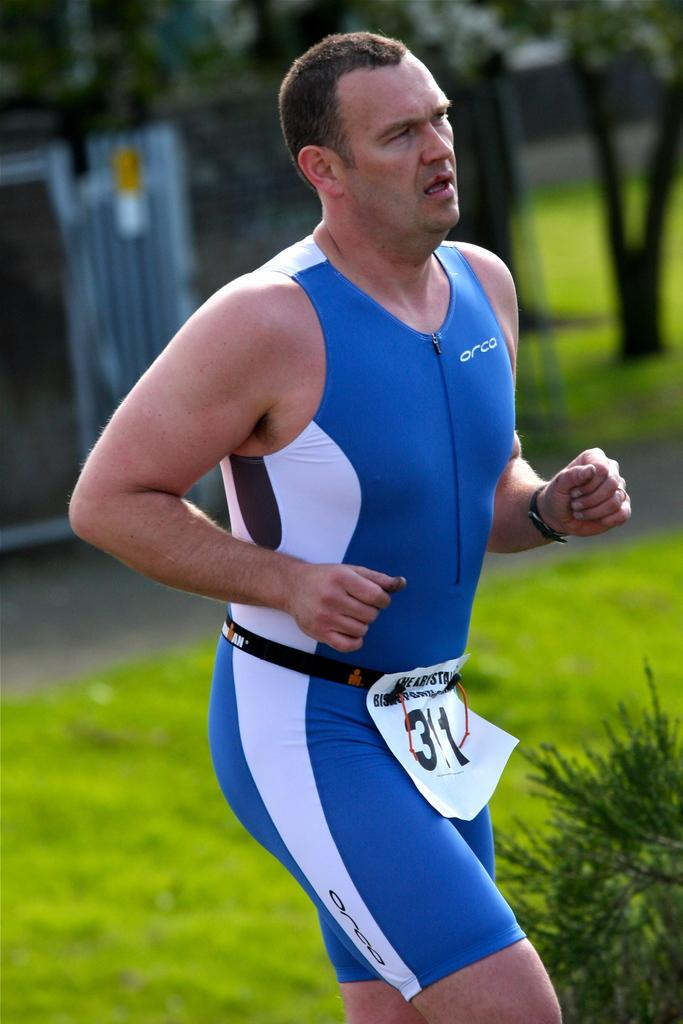<image>
Describe the image concisely. Runner wearing a white sign that has the number 311 on it. 